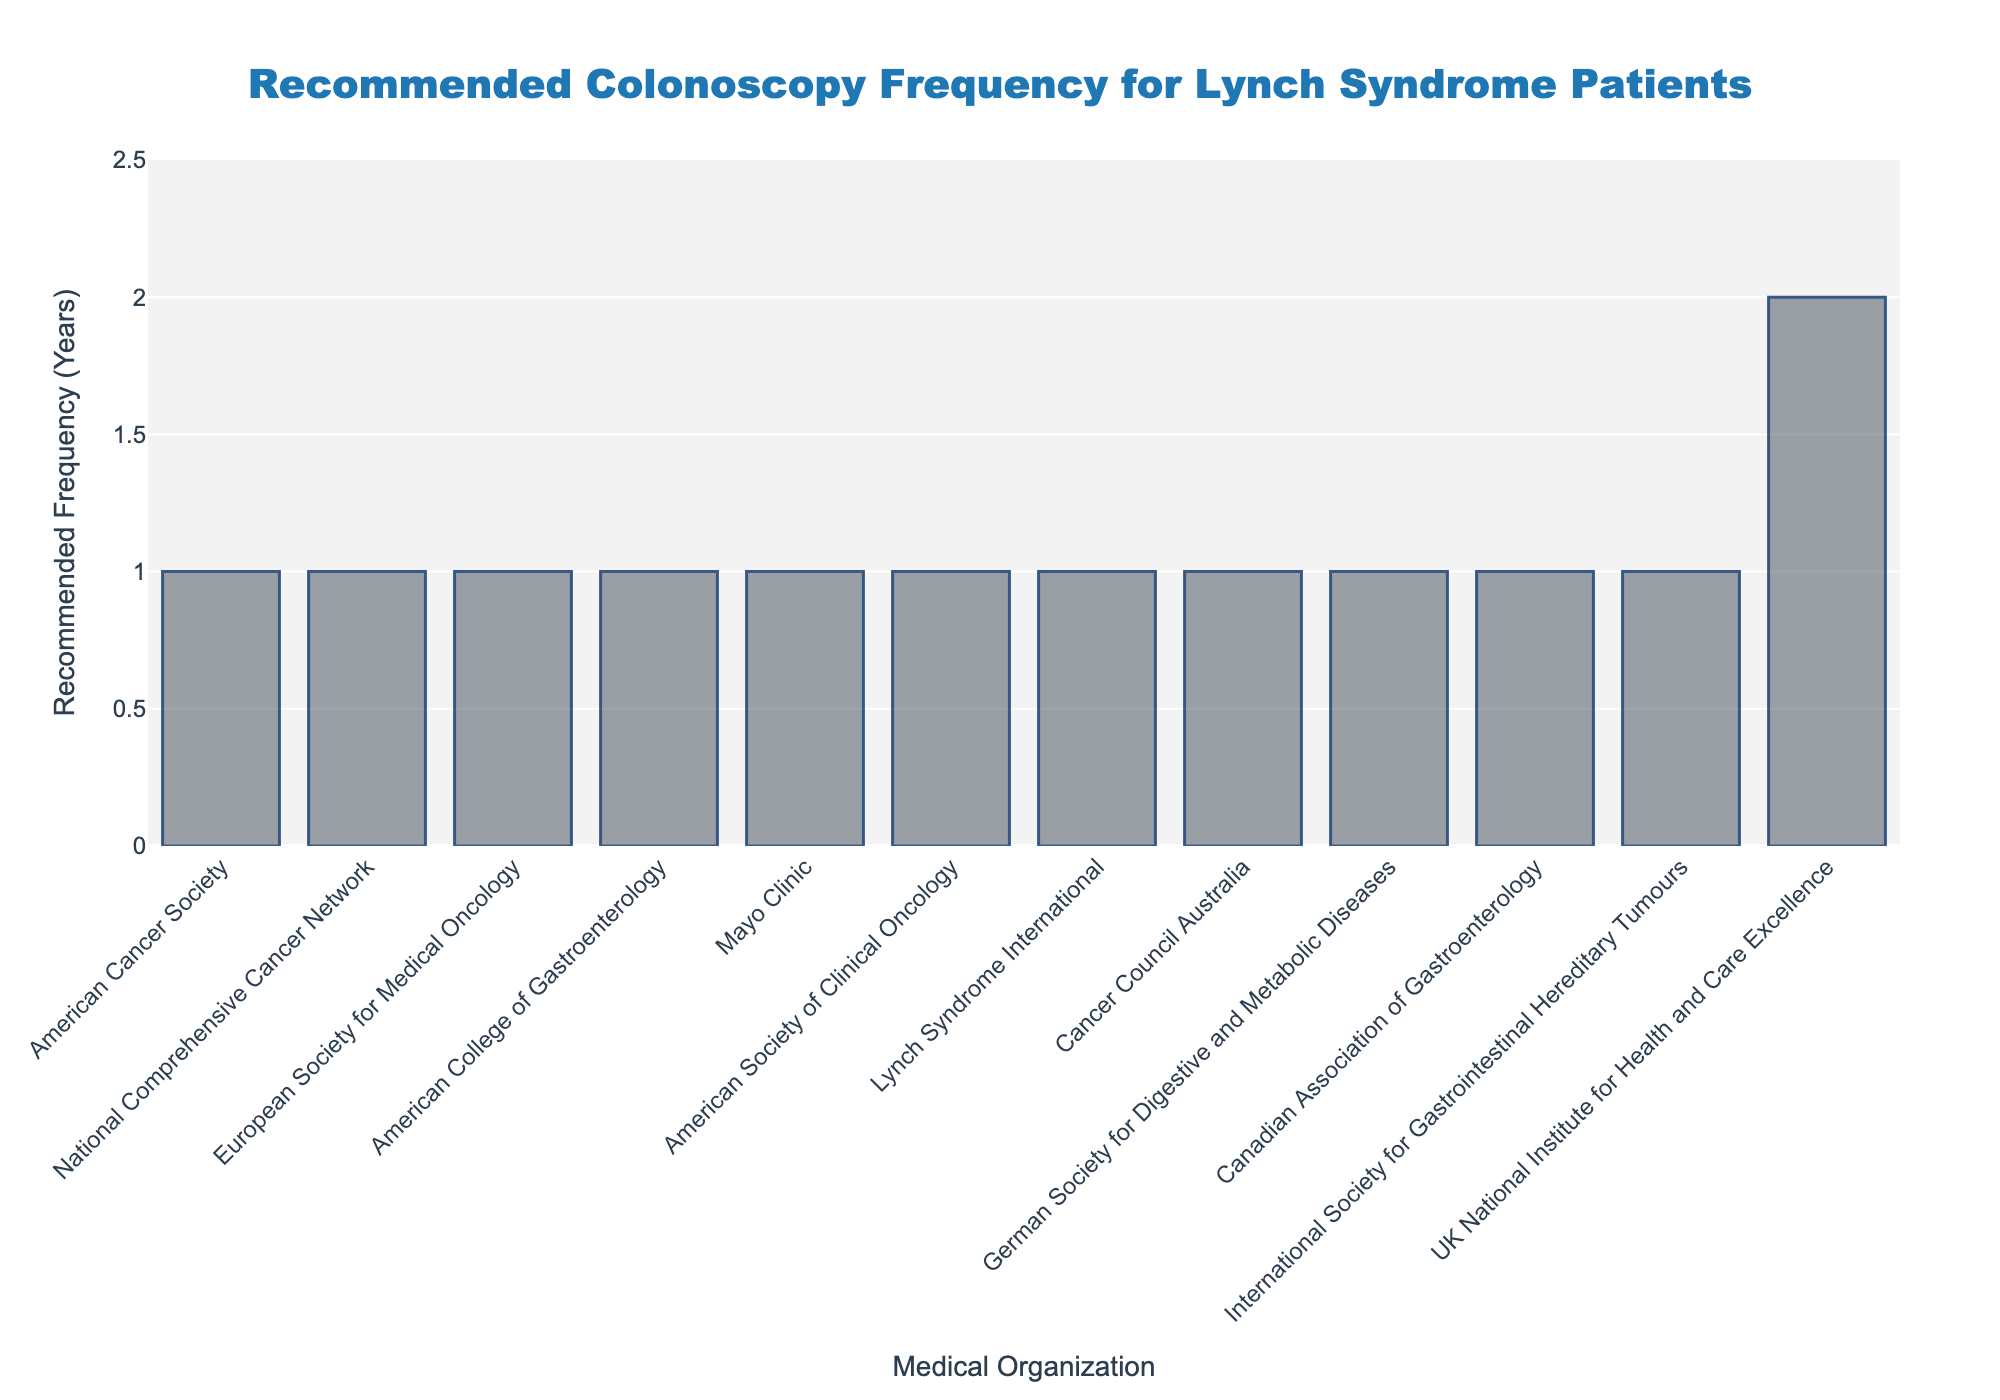What organization recommends the least frequent colonoscopy interval for Lynch syndrome patients? By examining the heights of the bars, the UK National Institute for Health and Care Excellence has the tallest bar, corresponding to a recommended frequency of 2 years, which is the least frequent interval.
Answer: UK National Institute for Health and Care Excellence How many organizations recommend colonoscopy intervals of 1 year? By counting the bars with heights indicating 1 year, we see the following organizations: American College of Gastroenterology, Mayo Clinic, and German Society for Digestive and Metabolic Diseases. This totals to 3 organizations.
Answer: 3 Which organizations recommend colonoscopy intervals of 1-2 years? By observing the heights of the bars, the organizations with a frequency range of 1-2 years are: American Cancer Society, National Comprehensive Cancer Network, European Society for Medical Oncology, American Society of Clinical Oncology, Lynch Syndrome International, Cancer Council Australia, Canadian Association of Gastroenterology, and International Society for Gastrointestinal Hereditary Tumours.
Answer: 8 Is there any organization recommending more than 2 years for colonoscopy intervals? By checking the y-axis values, all the bars have frequencies of 2 years or less. No bar indicates more than 2 years.
Answer: No Compare the colonoscopy recommendations of the American College of Gastroenterology and the UK National Institute for Health and Care Excellence. The bar corresponding to the American College of Gastroenterology has a height indicating a frequency of 1 year, whereas the UK National Institute for Health and Care Excellence has a frequency of 2 years. Thus, the American College of Gastroenterology recommends more frequent colonoscopies than the UK National Institute for Health and Care Excellence.
Answer: American College of Gastroenterology recommends more frequent colonoscopies What is the average recommended colonoscopy frequency among all organizations? Calculating the average from the frequency values: [1, 1, 1, 1, 1-2, 1-2, 1-2, 1-2, 2, 1-2, 1-2]. Converting ranges to their average values: 1, 1, 1, 1, 1.5, 1.5, 1.5, 1.5, 2, 1.5, 1.5. Sum these values and divide by the number of organizations: (1+1+1+1+1.5+1.5+1.5+1.5+2+1.5+1.5)/11 = 1.36.
Answer: 1.36 Which organization recommends the same frequency as the Mayo Clinic? Identifying the bar with the same height as the Mayo Clinic, which indicates 1 year, the organizations are American College of Gastroenterology and German Society for Digestive and Metabolic Diseases.
Answer: American College of Gastroenterology and German Society for Digestive and Metabolic Diseases 